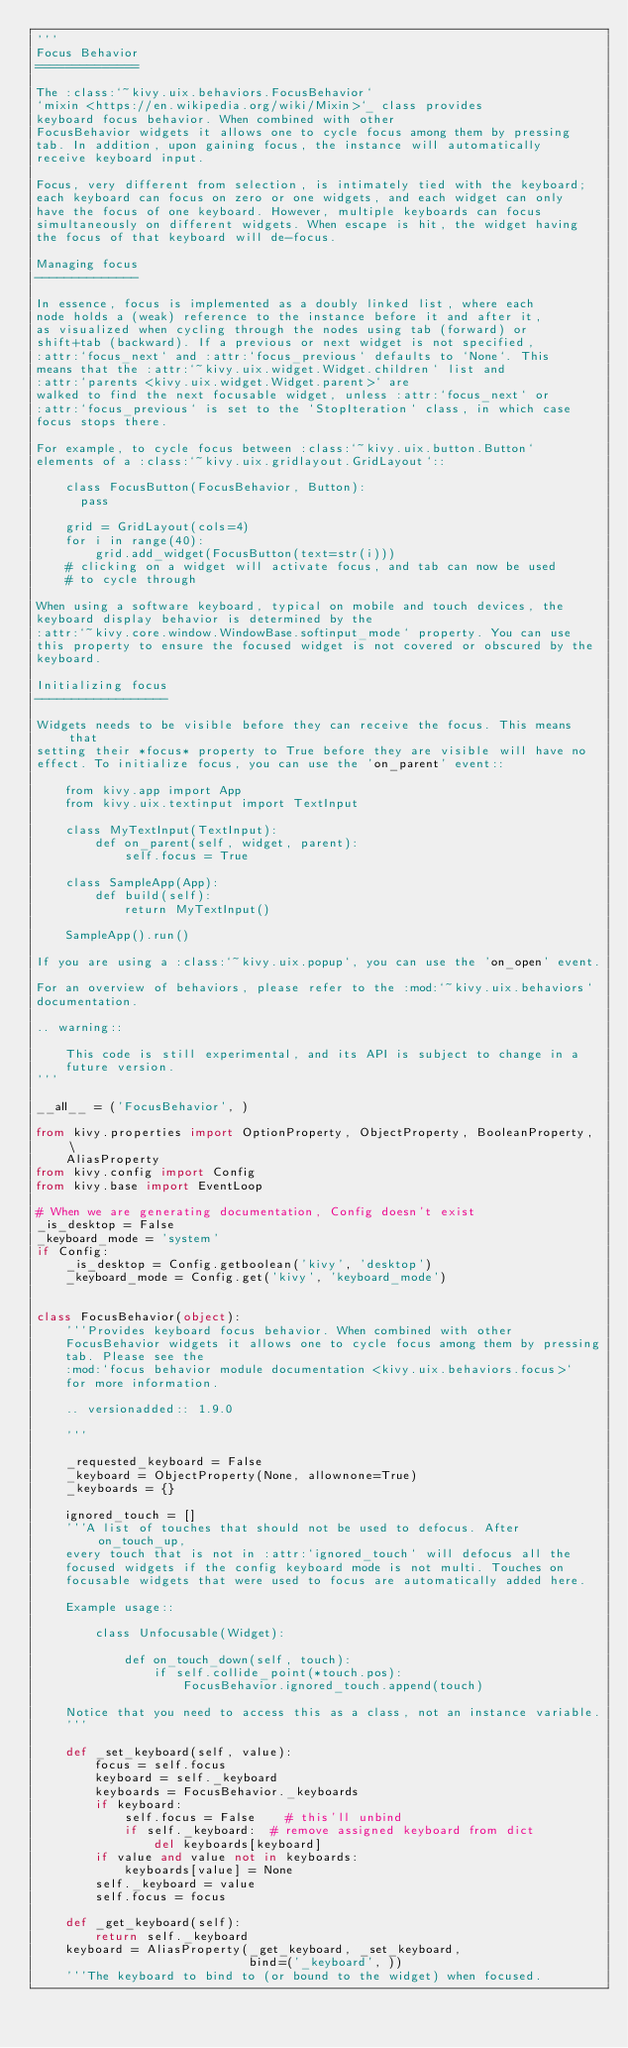<code> <loc_0><loc_0><loc_500><loc_500><_Python_>'''
Focus Behavior
==============

The :class:`~kivy.uix.behaviors.FocusBehavior`
`mixin <https://en.wikipedia.org/wiki/Mixin>`_ class provides
keyboard focus behavior. When combined with other
FocusBehavior widgets it allows one to cycle focus among them by pressing
tab. In addition, upon gaining focus, the instance will automatically
receive keyboard input.

Focus, very different from selection, is intimately tied with the keyboard;
each keyboard can focus on zero or one widgets, and each widget can only
have the focus of one keyboard. However, multiple keyboards can focus
simultaneously on different widgets. When escape is hit, the widget having
the focus of that keyboard will de-focus.

Managing focus
--------------

In essence, focus is implemented as a doubly linked list, where each
node holds a (weak) reference to the instance before it and after it,
as visualized when cycling through the nodes using tab (forward) or
shift+tab (backward). If a previous or next widget is not specified,
:attr:`focus_next` and :attr:`focus_previous` defaults to `None`. This
means that the :attr:`~kivy.uix.widget.Widget.children` list and
:attr:`parents <kivy.uix.widget.Widget.parent>` are
walked to find the next focusable widget, unless :attr:`focus_next` or
:attr:`focus_previous` is set to the `StopIteration` class, in which case
focus stops there.

For example, to cycle focus between :class:`~kivy.uix.button.Button`
elements of a :class:`~kivy.uix.gridlayout.GridLayout`::

    class FocusButton(FocusBehavior, Button):
      pass

    grid = GridLayout(cols=4)
    for i in range(40):
        grid.add_widget(FocusButton(text=str(i)))
    # clicking on a widget will activate focus, and tab can now be used
    # to cycle through

When using a software keyboard, typical on mobile and touch devices, the
keyboard display behavior is determined by the
:attr:`~kivy.core.window.WindowBase.softinput_mode` property. You can use
this property to ensure the focused widget is not covered or obscured by the
keyboard.

Initializing focus
------------------

Widgets needs to be visible before they can receive the focus. This means that
setting their *focus* property to True before they are visible will have no
effect. To initialize focus, you can use the 'on_parent' event::

    from kivy.app import App
    from kivy.uix.textinput import TextInput

    class MyTextInput(TextInput):
        def on_parent(self, widget, parent):
            self.focus = True

    class SampleApp(App):
        def build(self):
            return MyTextInput()

    SampleApp().run()

If you are using a :class:`~kivy.uix.popup`, you can use the 'on_open' event.

For an overview of behaviors, please refer to the :mod:`~kivy.uix.behaviors`
documentation.

.. warning::

    This code is still experimental, and its API is subject to change in a
    future version.
'''

__all__ = ('FocusBehavior', )

from kivy.properties import OptionProperty, ObjectProperty, BooleanProperty, \
    AliasProperty
from kivy.config import Config
from kivy.base import EventLoop

# When we are generating documentation, Config doesn't exist
_is_desktop = False
_keyboard_mode = 'system'
if Config:
    _is_desktop = Config.getboolean('kivy', 'desktop')
    _keyboard_mode = Config.get('kivy', 'keyboard_mode')


class FocusBehavior(object):
    '''Provides keyboard focus behavior. When combined with other
    FocusBehavior widgets it allows one to cycle focus among them by pressing
    tab. Please see the
    :mod:`focus behavior module documentation <kivy.uix.behaviors.focus>`
    for more information.

    .. versionadded:: 1.9.0

    '''

    _requested_keyboard = False
    _keyboard = ObjectProperty(None, allownone=True)
    _keyboards = {}

    ignored_touch = []
    '''A list of touches that should not be used to defocus. After on_touch_up,
    every touch that is not in :attr:`ignored_touch` will defocus all the
    focused widgets if the config keyboard mode is not multi. Touches on
    focusable widgets that were used to focus are automatically added here.

    Example usage::

        class Unfocusable(Widget):

            def on_touch_down(self, touch):
                if self.collide_point(*touch.pos):
                    FocusBehavior.ignored_touch.append(touch)

    Notice that you need to access this as a class, not an instance variable.
    '''

    def _set_keyboard(self, value):
        focus = self.focus
        keyboard = self._keyboard
        keyboards = FocusBehavior._keyboards
        if keyboard:
            self.focus = False    # this'll unbind
            if self._keyboard:  # remove assigned keyboard from dict
                del keyboards[keyboard]
        if value and value not in keyboards:
            keyboards[value] = None
        self._keyboard = value
        self.focus = focus

    def _get_keyboard(self):
        return self._keyboard
    keyboard = AliasProperty(_get_keyboard, _set_keyboard,
                             bind=('_keyboard', ))
    '''The keyboard to bind to (or bound to the widget) when focused.
</code> 